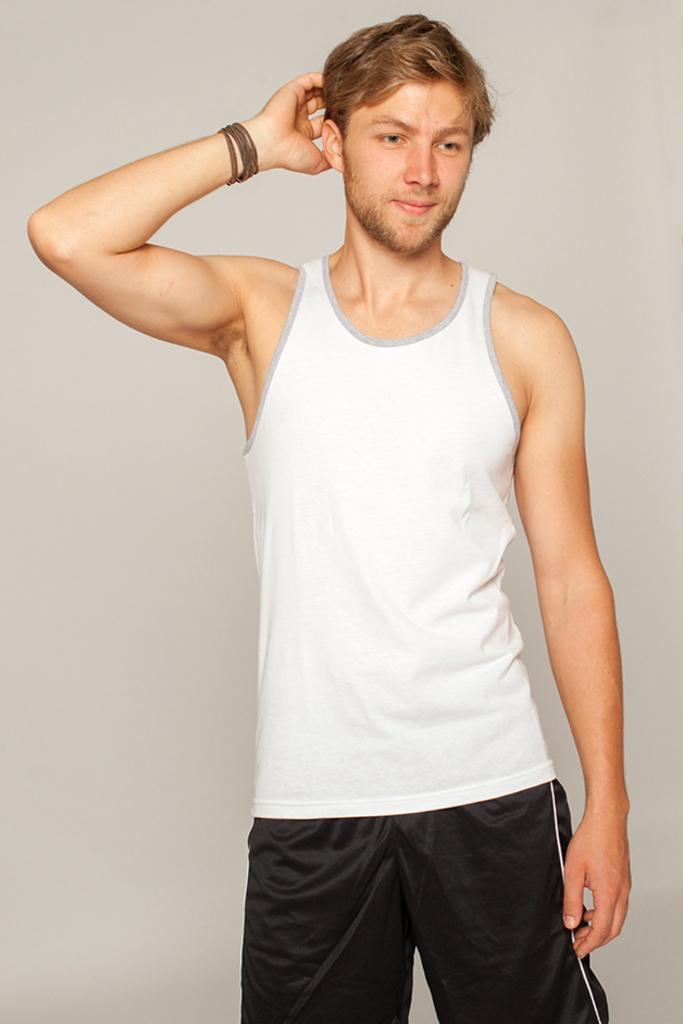What is the main subject of the image? The main subject of the image is a man standing. What can be observed about the man's attire? The man is wearing clothes. Are there any accessories or additional items visible on the man? Yes, the man has a hand band. What is the man's facial expression in the image? The man is smiling. What is the man's route to the nearest chess tournament in the image? There is no information about a chess tournament or a route in the image. 